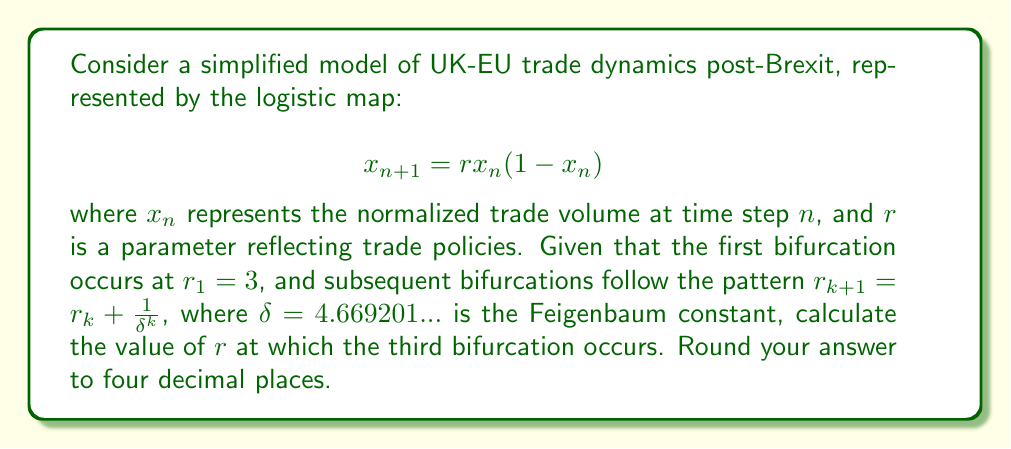Can you solve this math problem? To solve this problem, we need to follow these steps:

1) We know that the first bifurcation occurs at $r_1 = 3$.

2) We need to find $r_2$ and $r_3$ using the given formula:

   $r_{k+1} = r_k + \frac{1}{δ^k}$

3) For $r_2$:
   $$r_2 = r_1 + \frac{1}{δ^1} = 3 + \frac{1}{4.669201} = 3.2142...$$

4) For $r_3$ (our target):
   $$r_3 = r_2 + \frac{1}{δ^2}$$

5) Substituting the value of $r_2$:
   $$r_3 = 3.2142... + \frac{1}{(4.669201)^2}$$

6) Calculating:
   $$r_3 = 3.2142... + 0.0458... = 3.2600...$$

7) Rounding to four decimal places:
   $$r_3 ≈ 3.2600$$

This value represents the point at which the trade dynamics model transitions from a 4-period cycle to an 8-period cycle, indicating increased complexity in the trade patterns between the UK and EU post-Brexit.
Answer: 3.2600 